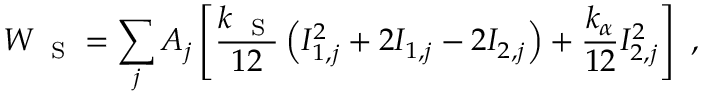<formula> <loc_0><loc_0><loc_500><loc_500>W _ { S } = \sum _ { j } A _ { j } \left [ \frac { k _ { S } } { 1 2 } \left ( I _ { 1 , j } ^ { 2 } + 2 I _ { 1 , j } - 2 I _ { 2 , j } \right ) + \frac { k _ { \alpha } } { 1 2 } I _ { 2 , j } ^ { 2 } \right ] \ ,</formula> 